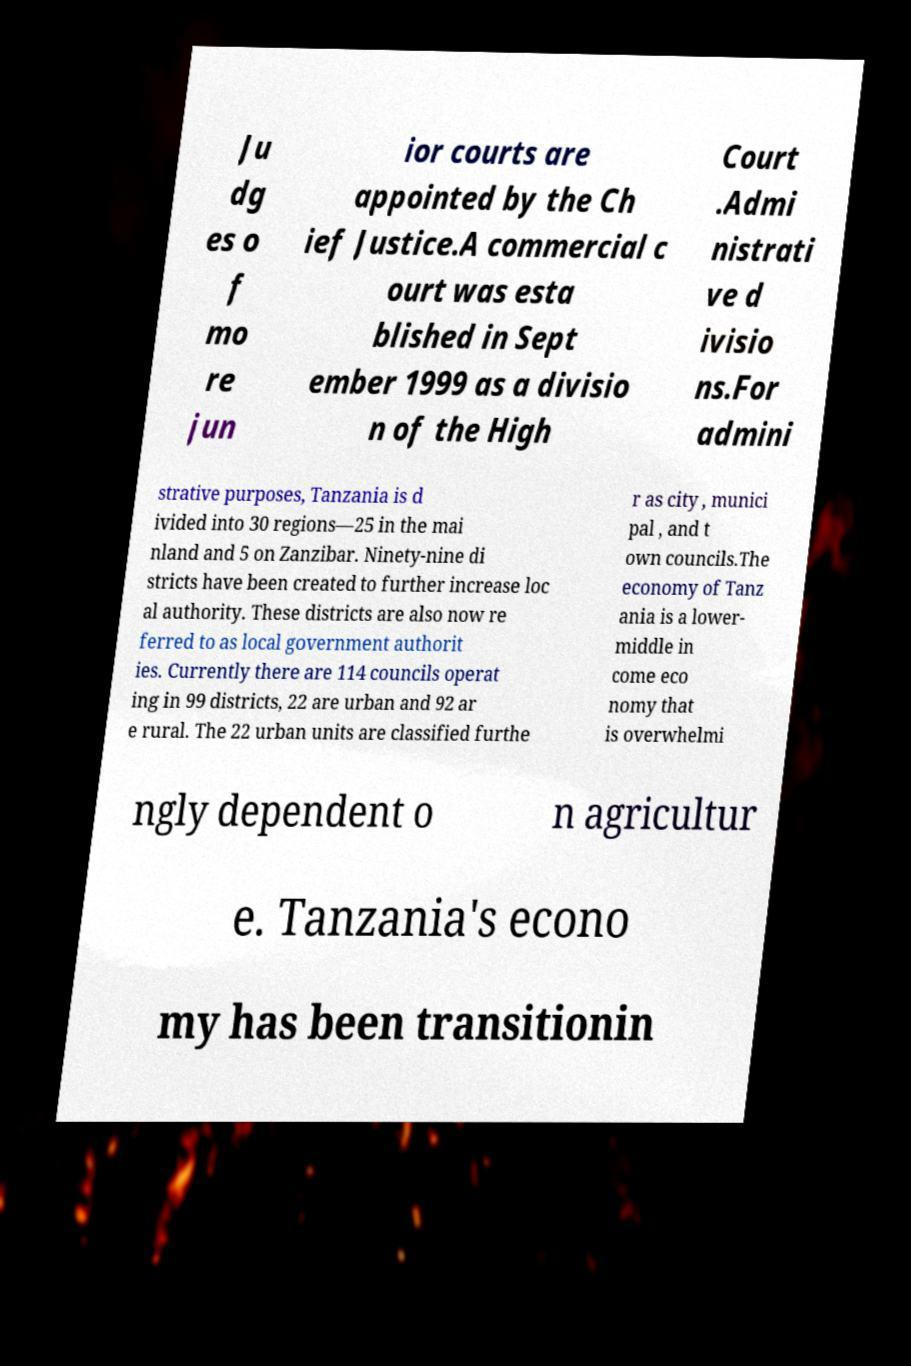Can you accurately transcribe the text from the provided image for me? Ju dg es o f mo re jun ior courts are appointed by the Ch ief Justice.A commercial c ourt was esta blished in Sept ember 1999 as a divisio n of the High Court .Admi nistrati ve d ivisio ns.For admini strative purposes, Tanzania is d ivided into 30 regions—25 in the mai nland and 5 on Zanzibar. Ninety-nine di stricts have been created to further increase loc al authority. These districts are also now re ferred to as local government authorit ies. Currently there are 114 councils operat ing in 99 districts, 22 are urban and 92 ar e rural. The 22 urban units are classified furthe r as city , munici pal , and t own councils.The economy of Tanz ania is a lower- middle in come eco nomy that is overwhelmi ngly dependent o n agricultur e. Tanzania's econo my has been transitionin 